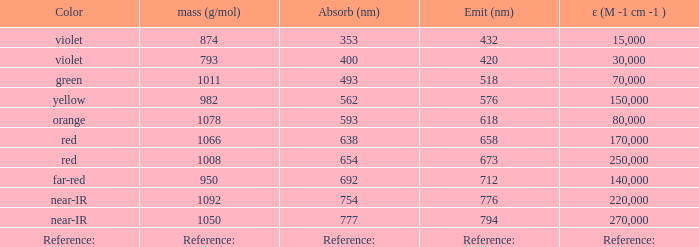What is the Absorbtion (in nanometers) of the color Violet with an emission of 432 nm? 353.0. 